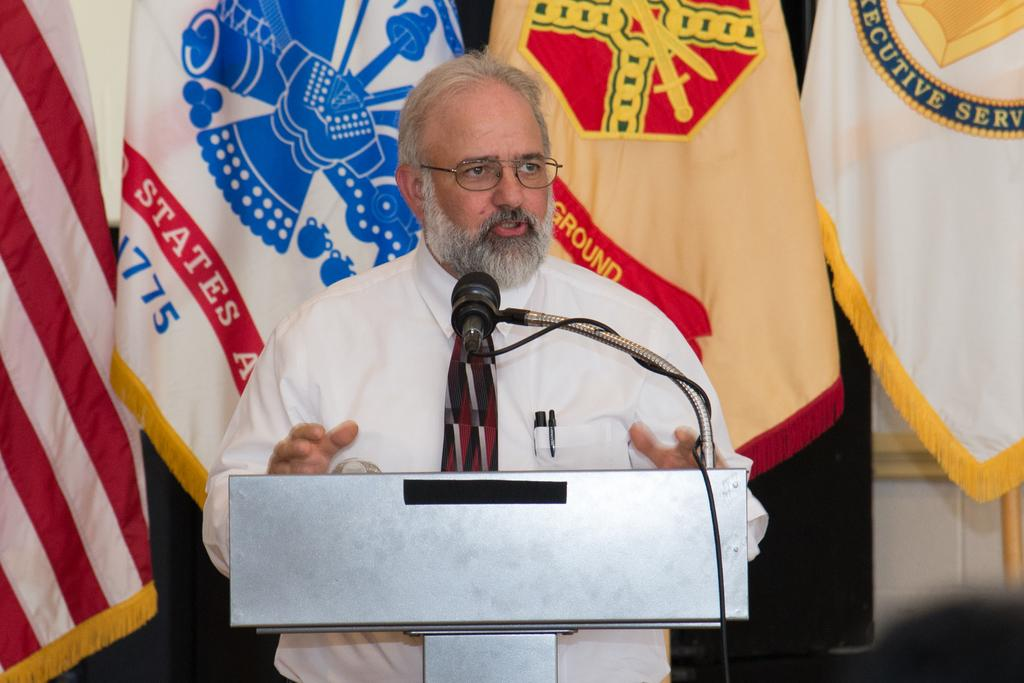Provide a one-sentence caption for the provided image. A man stands behind a podium with a flag behind him that has "States" on a red background. 